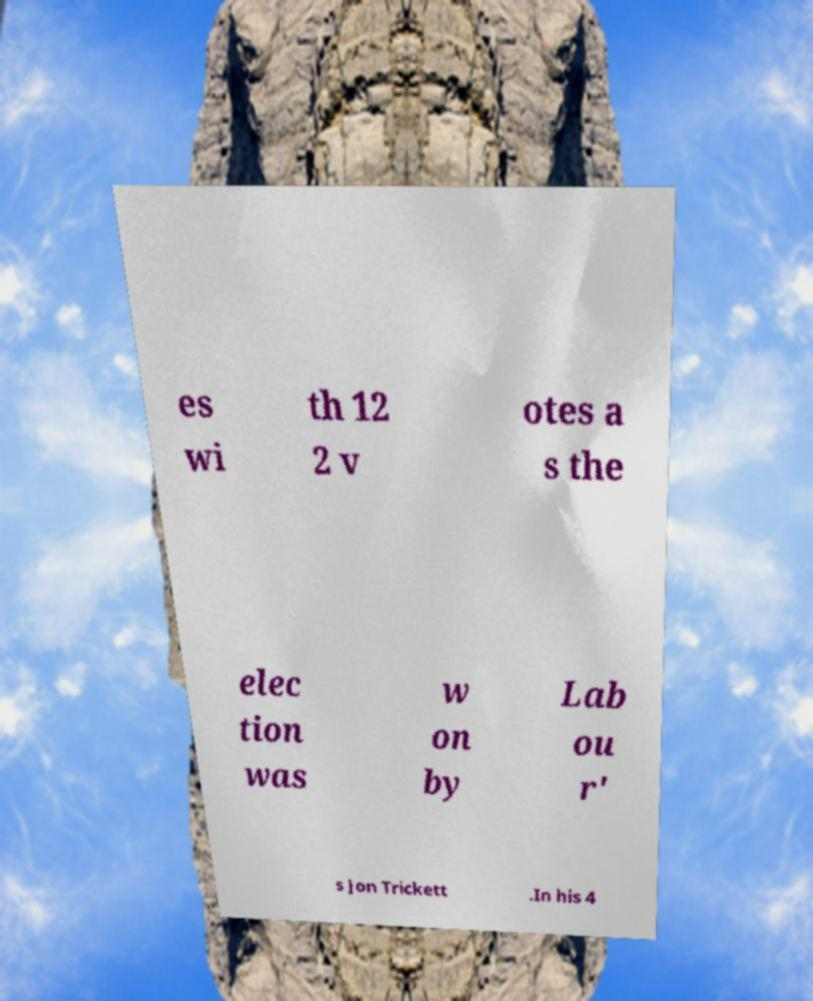For documentation purposes, I need the text within this image transcribed. Could you provide that? es wi th 12 2 v otes a s the elec tion was w on by Lab ou r' s Jon Trickett .In his 4 